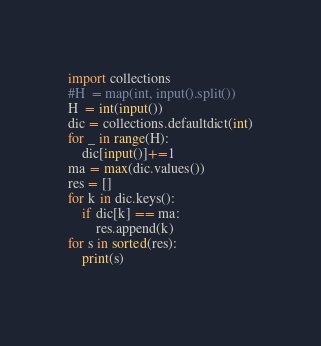<code> <loc_0><loc_0><loc_500><loc_500><_Python_>import collections
#H  = map(int, input().split())
H  = int(input())
dic = collections.defaultdict(int)
for _ in range(H):
    dic[input()]+=1
ma = max(dic.values())
res = []
for k in dic.keys():
    if dic[k] == ma:
        res.append(k)
for s in sorted(res):
    print(s)
        
</code> 